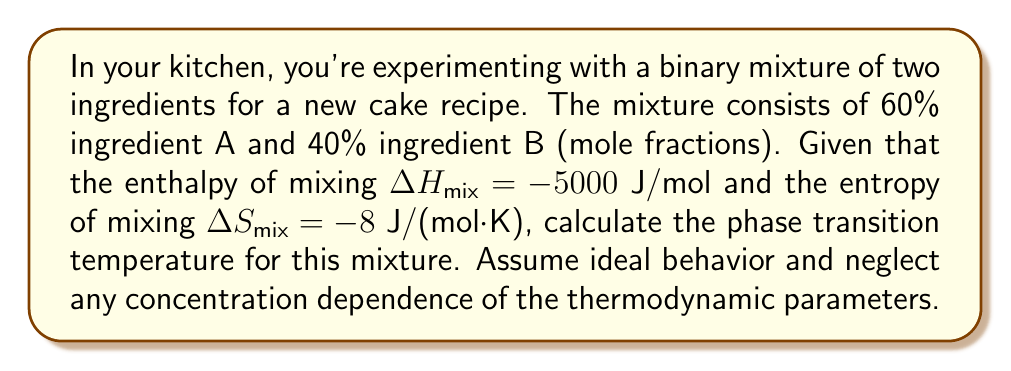What is the answer to this math problem? To solve this problem, we'll use the Gibbs free energy of mixing ($\Delta G_{mix}$) and its relationship to the enthalpy and entropy of mixing. At the phase transition temperature, $\Delta G_{mix} = 0$.

Step 1: Write the equation for Gibbs free energy of mixing:
$$\Delta G_{mix} = \Delta H_{mix} - T\Delta S_{mix}$$

Step 2: Set $\Delta G_{mix} = 0$ at the phase transition temperature:
$$0 = \Delta H_{mix} - T\Delta S_{mix}$$

Step 3: Rearrange the equation to solve for temperature T:
$$T = \frac{\Delta H_{mix}}{\Delta S_{mix}}$$

Step 4: Substitute the given values:
$$T = \frac{-5000 \text{ J/mol}}{-8 \text{ J/(mol·K)}}$$

Step 5: Calculate the temperature:
$$T = 625 \text{ K}$$

Step 6: Convert to Celsius:
$$T = 625 - 273.15 = 351.85 \text{ °C}$$

Therefore, the phase transition temperature for this binary mixture is approximately 351.85°C.
Answer: 351.85°C 